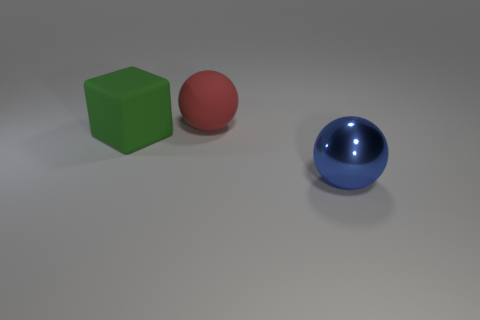Add 1 large blue spheres. How many objects exist? 4 Subtract all blocks. How many objects are left? 2 Subtract all blue rubber blocks. Subtract all green things. How many objects are left? 2 Add 1 blue shiny balls. How many blue shiny balls are left? 2 Add 2 large red matte objects. How many large red matte objects exist? 3 Subtract 0 blue cylinders. How many objects are left? 3 